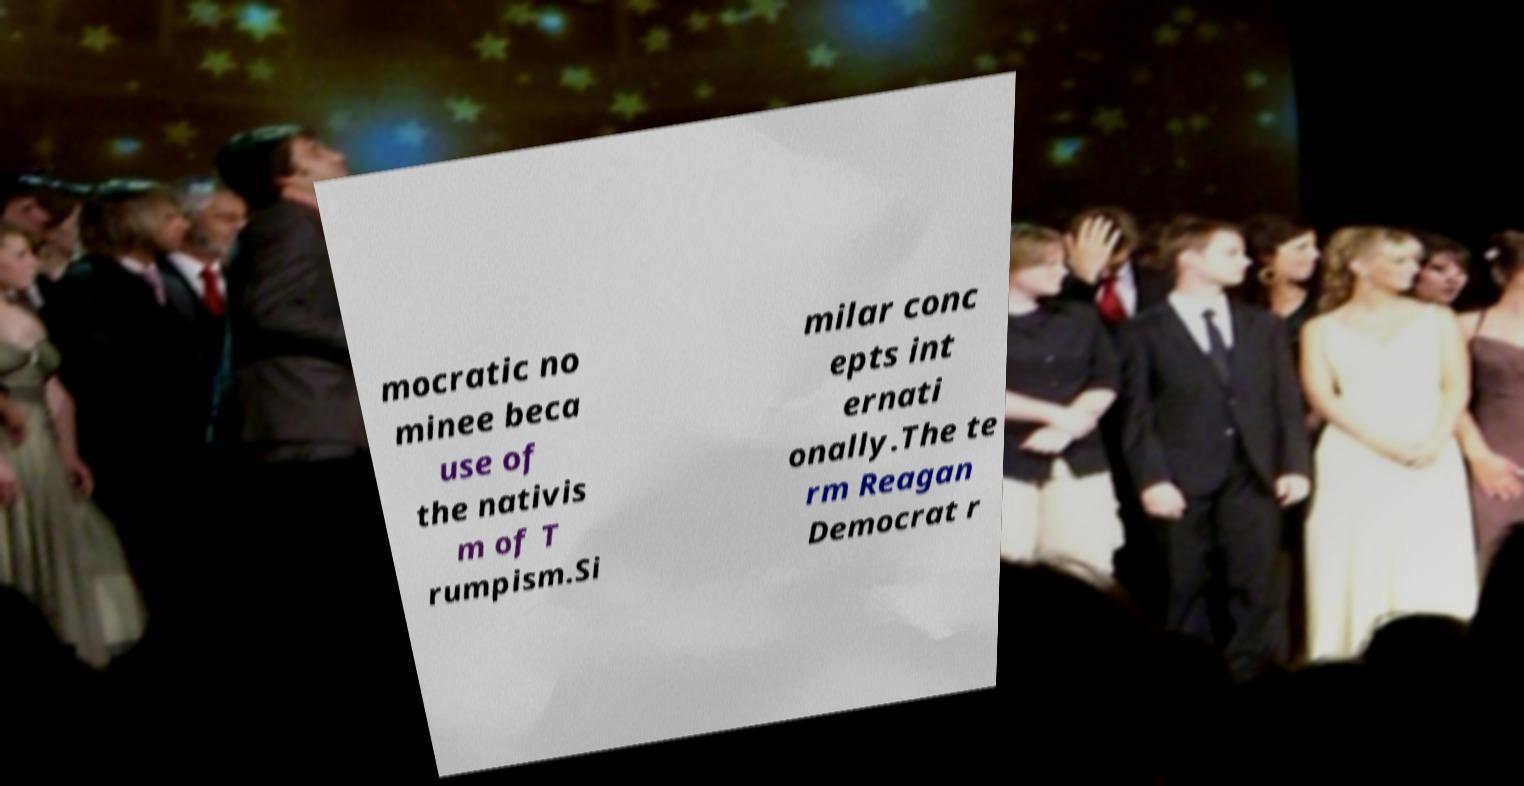What messages or text are displayed in this image? I need them in a readable, typed format. mocratic no minee beca use of the nativis m of T rumpism.Si milar conc epts int ernati onally.The te rm Reagan Democrat r 